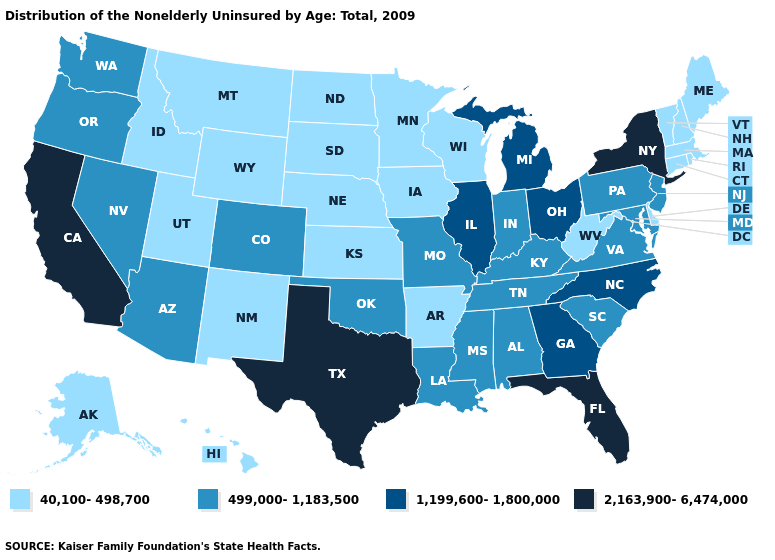Among the states that border Arkansas , which have the lowest value?
Short answer required. Louisiana, Mississippi, Missouri, Oklahoma, Tennessee. Which states have the lowest value in the Northeast?
Keep it brief. Connecticut, Maine, Massachusetts, New Hampshire, Rhode Island, Vermont. Name the states that have a value in the range 40,100-498,700?
Quick response, please. Alaska, Arkansas, Connecticut, Delaware, Hawaii, Idaho, Iowa, Kansas, Maine, Massachusetts, Minnesota, Montana, Nebraska, New Hampshire, New Mexico, North Dakota, Rhode Island, South Dakota, Utah, Vermont, West Virginia, Wisconsin, Wyoming. Name the states that have a value in the range 2,163,900-6,474,000?
Concise answer only. California, Florida, New York, Texas. What is the highest value in the MidWest ?
Quick response, please. 1,199,600-1,800,000. Does Alaska have the same value as Illinois?
Write a very short answer. No. Among the states that border Pennsylvania , which have the highest value?
Quick response, please. New York. Among the states that border Indiana , which have the highest value?
Keep it brief. Illinois, Michigan, Ohio. Does Kansas have the highest value in the MidWest?
Write a very short answer. No. What is the highest value in the USA?
Write a very short answer. 2,163,900-6,474,000. Does Georgia have a higher value than Alabama?
Quick response, please. Yes. Does Illinois have the lowest value in the MidWest?
Write a very short answer. No. Name the states that have a value in the range 1,199,600-1,800,000?
Answer briefly. Georgia, Illinois, Michigan, North Carolina, Ohio. Name the states that have a value in the range 1,199,600-1,800,000?
Answer briefly. Georgia, Illinois, Michigan, North Carolina, Ohio. Name the states that have a value in the range 2,163,900-6,474,000?
Write a very short answer. California, Florida, New York, Texas. 